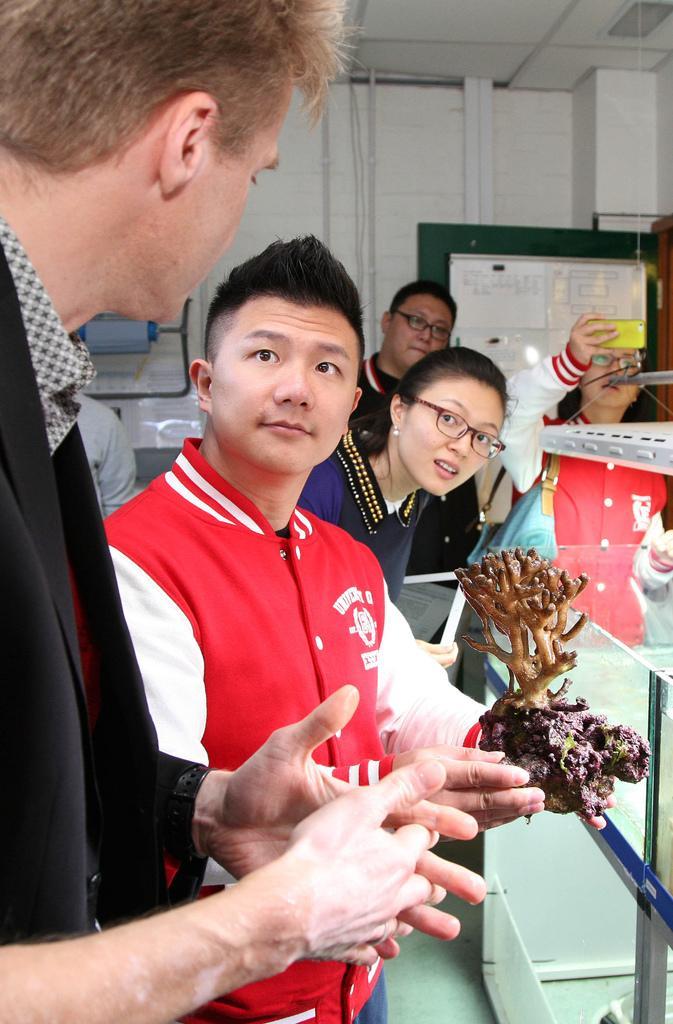Can you describe this image briefly? In this image I can see a couple of people among them one person standing on the left hand side is facing towards the back person beside him is holding a specimen. I can see a glass chamber, a wall behind them with some papers and some objects. I can see a board with some text on the right hand side. I can see a false ceiling. 